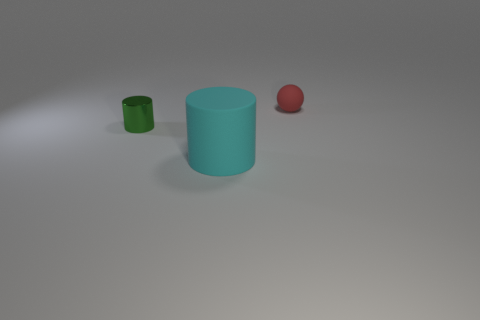Are there any other things that have the same material as the small cylinder?
Your answer should be very brief. No. The small thing on the left side of the red rubber ball is what color?
Ensure brevity in your answer.  Green. What is the tiny object that is in front of the tiny thing on the right side of the tiny green cylinder made of?
Your answer should be compact. Metal. Is the number of small spheres that are in front of the large object less than the number of things that are in front of the small green shiny cylinder?
Your answer should be compact. Yes. What number of cyan things are shiny things or small balls?
Give a very brief answer. 0. Is the number of green metallic objects that are on the right side of the large cyan thing the same as the number of tiny objects?
Ensure brevity in your answer.  No. How many objects are either small red objects or tiny objects that are left of the tiny red ball?
Provide a short and direct response. 2. Is there a sphere that has the same material as the cyan cylinder?
Offer a very short reply. Yes. What color is the large object that is the same shape as the small green thing?
Your answer should be very brief. Cyan. Is the large thing made of the same material as the small thing to the left of the rubber cylinder?
Your answer should be very brief. No. 